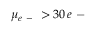Convert formula to latex. <formula><loc_0><loc_0><loc_500><loc_500>\mu _ { e - } > 3 0 \, e -</formula> 